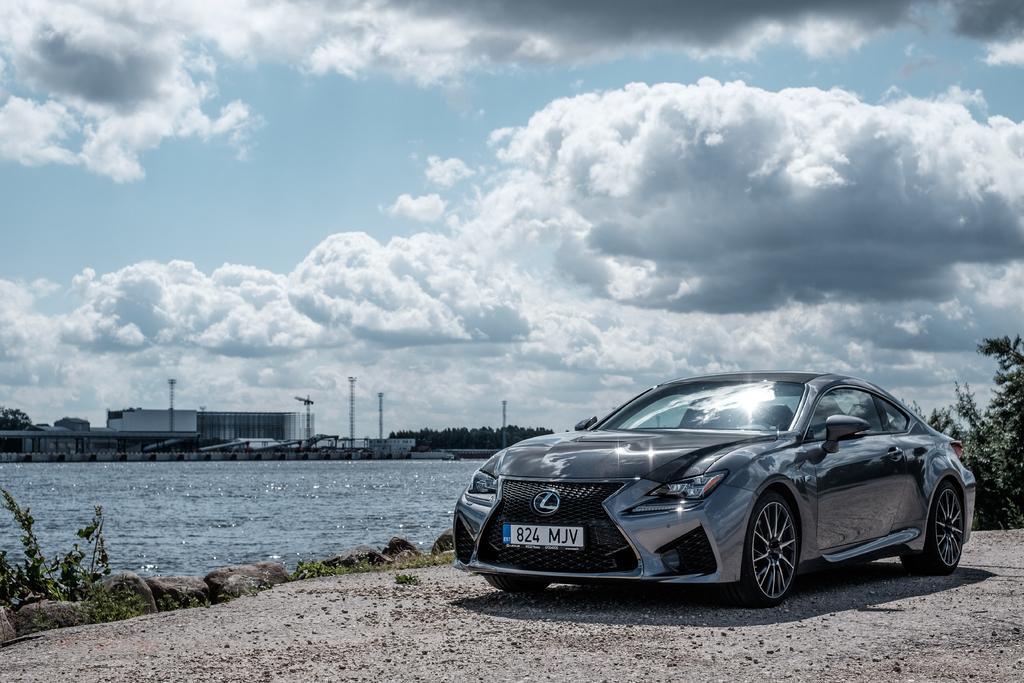Could you give a brief overview of what you see in this image? In this image, on the right there is a car. At the bottom there are stones, plants, land, water, waves. In the background there are trees, building, poles, sky and clouds. 